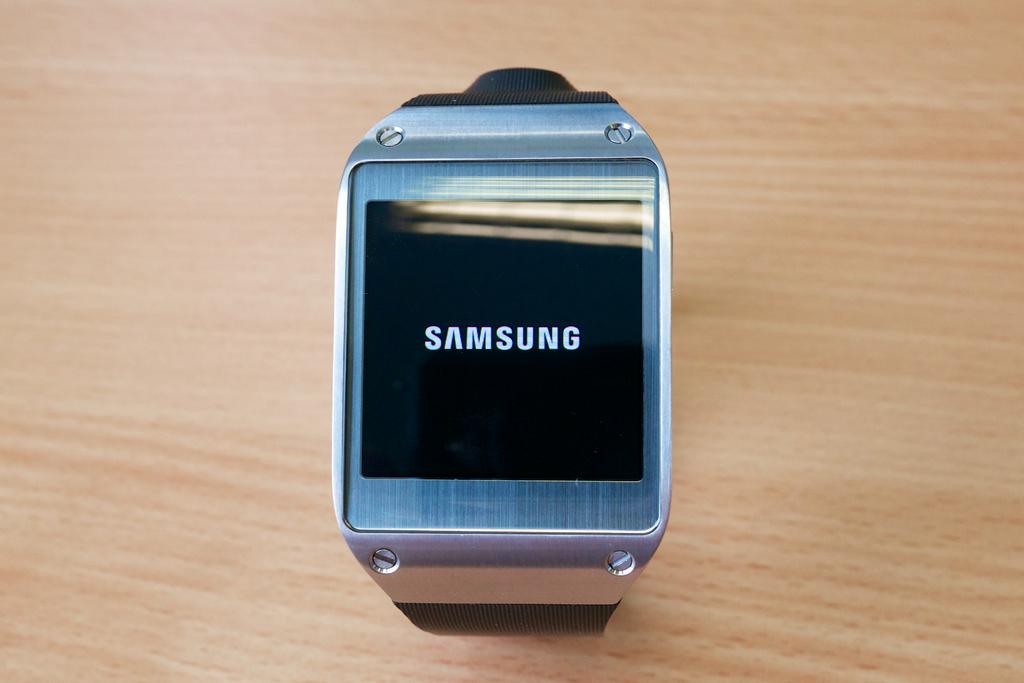<image>
Present a compact description of the photo's key features. The silver Samsung watch has an LCD screen. 